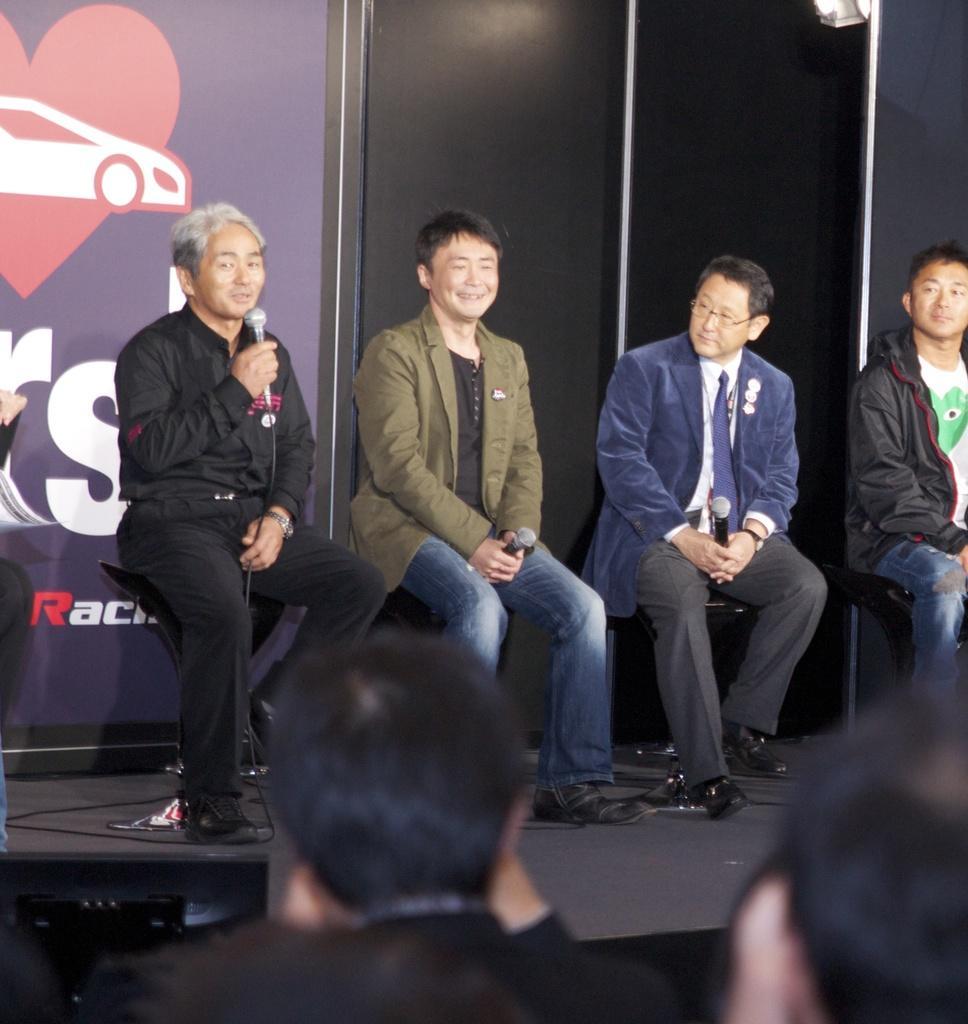How would you summarize this image in a sentence or two? In this image in the center there are some people who are sitting on chairs, and two of them are holding mikes and one person is talking. At the bottom there are two persons, and in the background there is a board. 